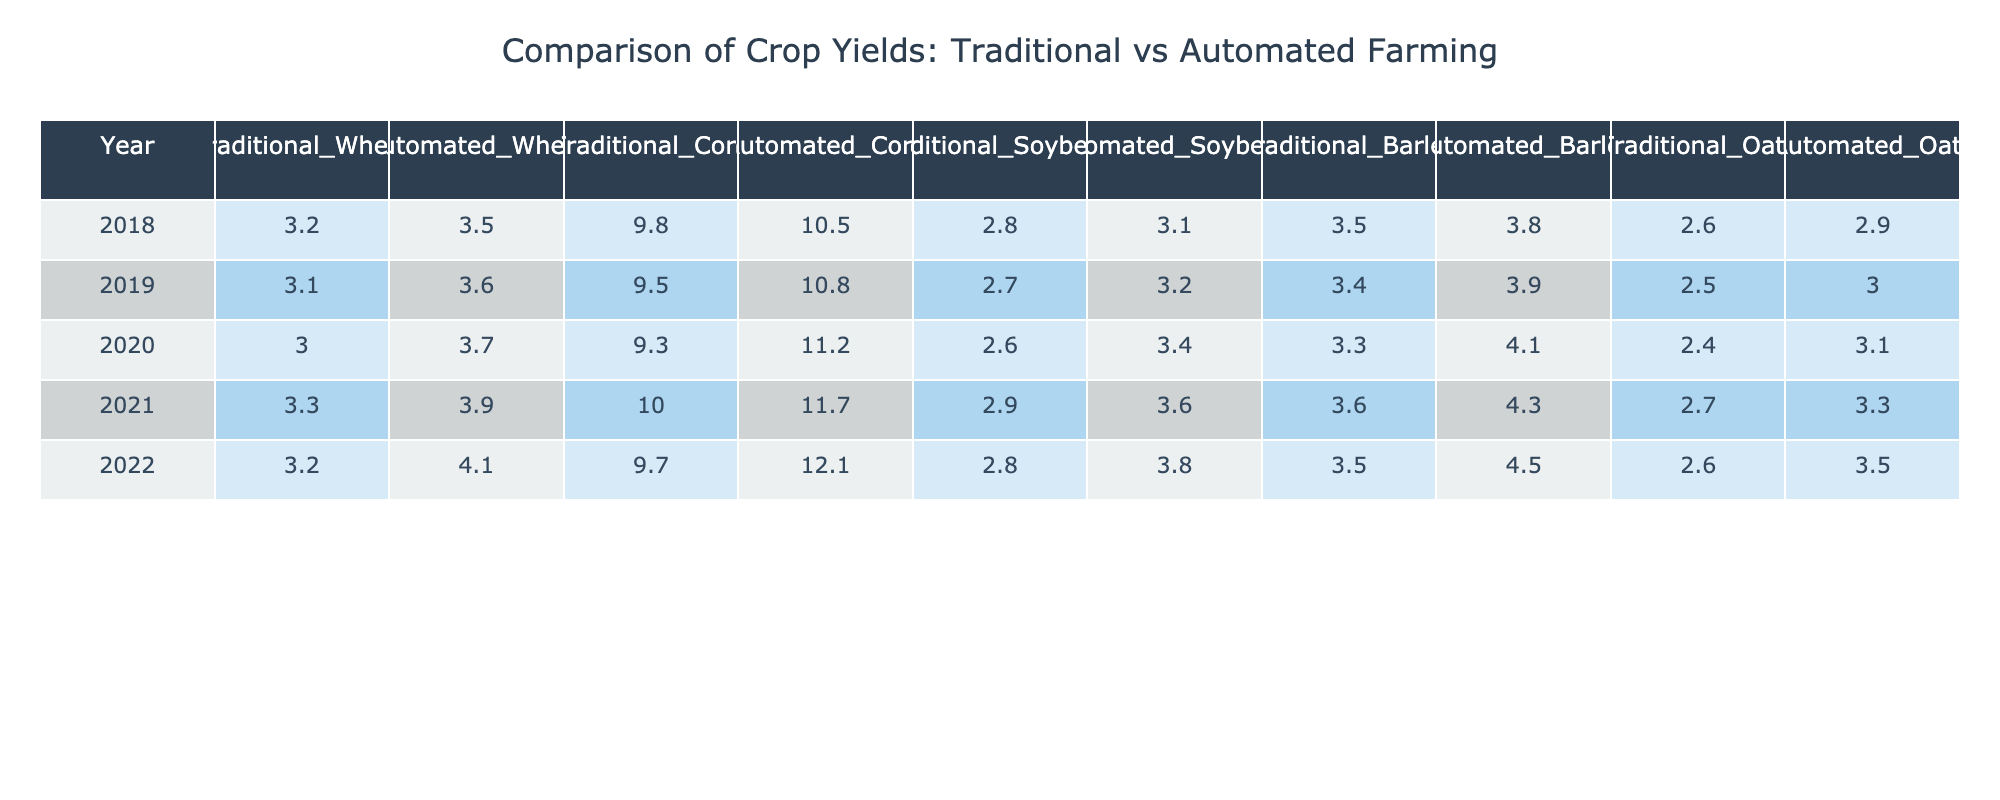What was the yield of automated corn in 2020? In the year 2020, the yield for automated corn is found by looking at the corresponding cell in the automated corn column, which is 11.2.
Answer: 11.2 What is the difference in yield for traditional wheat between 2018 and 2022? The traditional wheat yield in 2018 is 3.2, and in 2022 it is 3.2 as well. The difference is 3.2 - 3.2 = 0.
Answer: 0 What is the average yield of automated soybeans over the five years? To find the average, we add the yields for automated soybeans from each year: (3.1 + 3.2 + 3.4 + 3.6 + 3.8) = 17.1. Then, we divide by 5 (the number of years): 17.1 / 5 = 3.42.
Answer: 3.42 Did the yield of automated barley ever exceed the yield of traditional barley in any year? We compare each year's yield: in 2018, 3.8 > 3.5; in 2019, 3.9 > 3.4; in 2020, 4.1 > 3.3; in 2021, 4.3 > 3.6; in 2022, 4.5 > 3.5. Automated barley exceeded traditional barley in all years.
Answer: Yes In which year was the yield of automated corn the highest? We assess the yields of automated corn for each year: 10.5 (2018), 10.8 (2019), 11.2 (2020), 11.7 (2021), and 12.1 (2022). The highest yield occurred in 2022, with the value of 12.1.
Answer: 2022 What is the total yield of traditional oats over 5 years? The total yield is the sum of traditional oats: 2.6 + 2.5 + 2.4 + 2.7 + 2.6 = 12.8.
Answer: 12.8 Which crop showed the most significant improvement in yield from traditional to automated methods in 2021? For 2021, the improvement for each crop is calculated: Wheat (3.3 to 3.9), Corn (10.0 to 11.7), Soybeans (2.9 to 3.6), Barley (3.6 to 4.3), and Oats (2.7 to 3.3). The largest improvement is for corn, which increased by 1.7.
Answer: Corn What was the yield of traditional soybeans in the year with the highest automated soybean yield? The highest yield for automated soybeans was in 2022, where the traditional yield for soybeans that year was 2.8.
Answer: 2.8 Compute the total yield difference of automated wheat and traditional wheat over the five years. The total for automated wheat is (3.5 + 3.6 + 3.7 + 3.9 + 4.1 = 18.8) and traditional wheat (3.2 + 3.1 + 3.0 + 3.3 + 3.2 = 15.8). The difference is 18.8 - 15.8 = 3.0.
Answer: 3.0 Was there any year in which traditional corn yield was equal to or greater than automated corn yield? Comparing yields shows traditional corn yields (9.8, 9.5, 9.3, 10.0, 9.7) against automated (10.5, 10.8, 11.2, 11.7, 12.1). None of the traditional corn values are equal or exceed the corresponding automated values.
Answer: No 